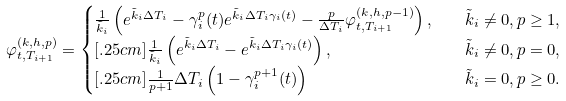<formula> <loc_0><loc_0><loc_500><loc_500>\varphi _ { t , T _ { i + 1 } } ^ { ( k , h , p ) } & = \begin{cases} \frac { 1 } { \tilde { k } _ { i } } \left ( e ^ { \tilde { k } _ { i } \Delta T _ { i } } - \gamma _ { i } ^ { p } ( t ) e ^ { \tilde { k } _ { i } \Delta T _ { i } \gamma _ { i } ( t ) } - \frac { p } { \Delta T _ { i } } \varphi _ { t , T _ { i + 1 } } ^ { ( k , h , p - 1 ) } \right ) , \quad & \tilde { k } _ { i } \neq 0 , p \geq 1 , \\ [ . 2 5 c m ] \frac { 1 } { \tilde { k } _ { i } } \left ( e ^ { \tilde { k } _ { i } \Delta T _ { i } } - e ^ { \tilde { k } _ { i } \Delta T _ { i } \gamma _ { i } ( t ) } \right ) , \quad & \tilde { k } _ { i } \neq 0 , p = 0 , \\ [ . 2 5 c m ] \frac { 1 } { p + 1 } \Delta T _ { i } \left ( 1 - \gamma _ { i } ^ { p + 1 } ( t ) \right ) & \tilde { k } _ { i } = 0 , p \geq 0 . \end{cases}</formula> 